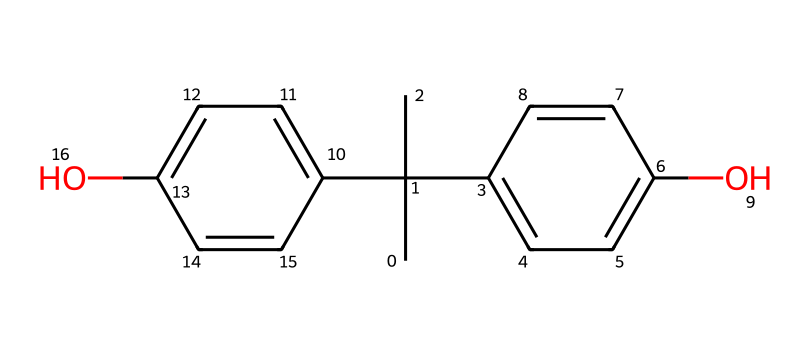What is the chemical name of this compound? The SMILES representation corresponds to a well-known toxic chemical used in plastics, identified as bisphenol A.
Answer: bisphenol A How many hydroxyl (–OH) functional groups are present in this molecule? In the structure, there are two hydroxyl groups indicated by the "O" connected to carbon atoms in the aromatic rings.
Answer: two What type of chemical structure is primarily present in bisphenol A? The chemical structure features a configuration of aromatic rings, which is typical for bisphenol compounds, indicating it is an aromatic compound.
Answer: aromatic What effect does bisphenol A have on human health? Bisphenol A is known to be an endocrine disruptor, affecting hormone function and potentially leading to various health issues.
Answer: endocrine disruptor How many carbon atoms are in bisphenol A? By analyzing the SMILES representation, the total number of carbon atoms in the structure adds up to 15.
Answer: 15 Does bisphenol A contain any toxic elements? The structure may not explicitly show toxic elements like heavy metals, but bisphenol A itself is classified as toxic and poses risks to health.
Answer: yes 